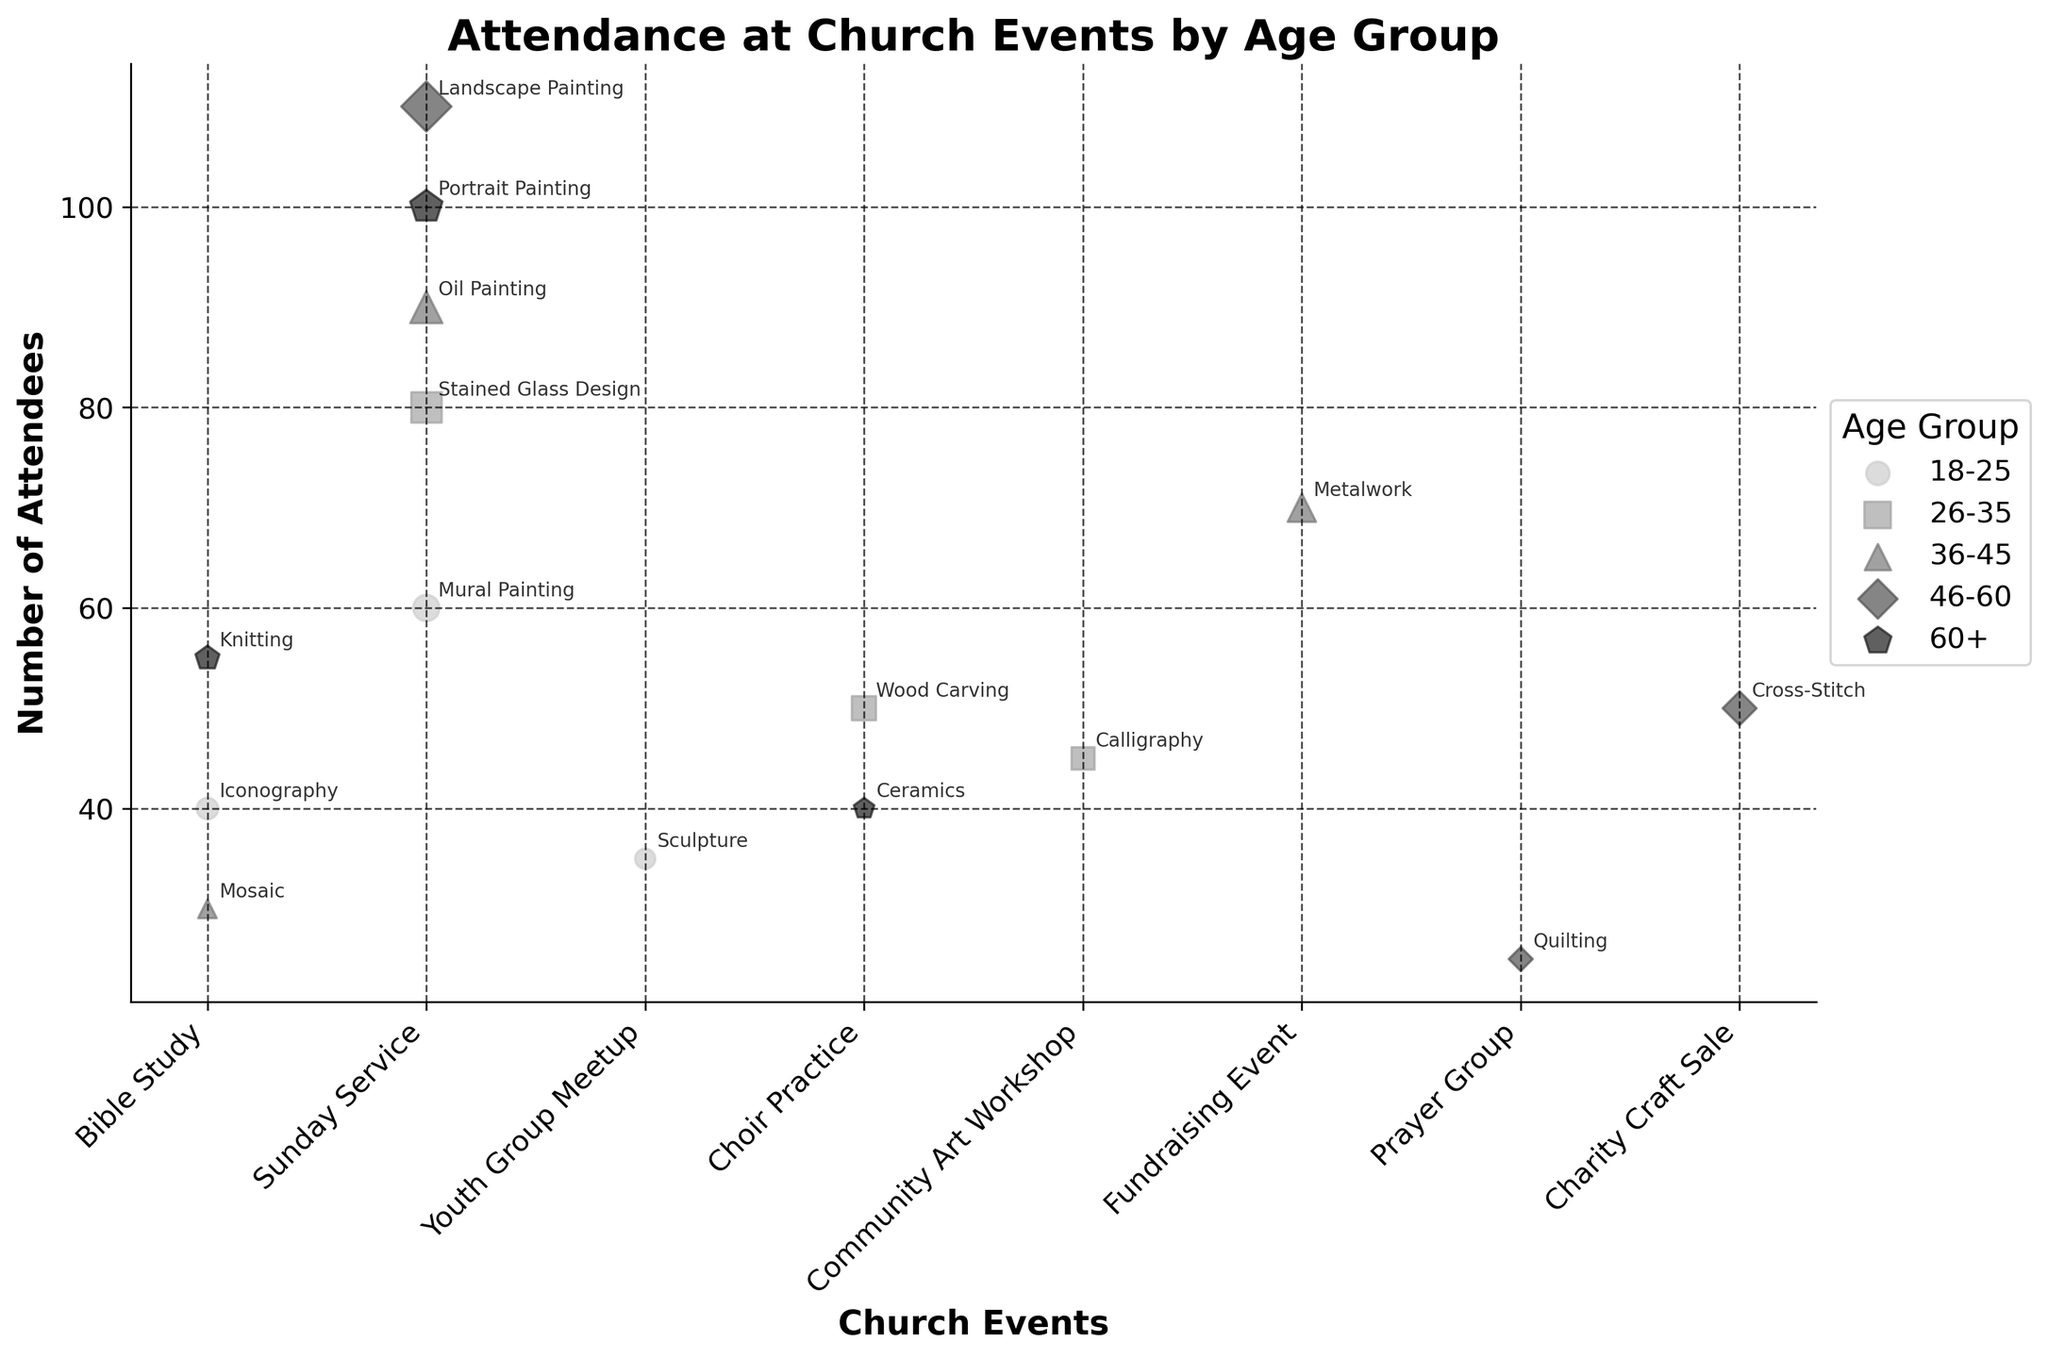what's the title of the plot? The title of the plot is displayed at the top in a larger, bold font. It provides a summary of what the plot represents. Look at the top of the chart to find the title.
Answer: Attendance at Church Events by Age Group how many attendees are there at the Community Art Workshop for age group 26-35? Identify the marker for the Community Art Workshop event and the age group 26-35, then look at the y-axis value where the marker is positioned.
Answer: 45 which age group has the highest attendance at Sunday Service? Compare the markers labeled 'Sunday Service' for all age groups and find which one is placed highest on the y-axis.
Answer: 46-60 what artistic interest is associated with the event that has 70 attendees for the age group 36-45? Locate the marker for the age group 36-45 with 70 attendees, find the corresponding event, and look at the annotation next to it that indicates the artistic interest.
Answer: Metalwork which event is most attended by the age group 18-25? Look for the markers associated with age group 18-25 and identify which one is positioned highest on the y-axis.
Answer: Sunday Service which age group participates in Choir Practice and what are their artistic interests? Find the markers labeled Choir Practice, then check the corresponding age groups and annotations for artistic interests.
Answer: 26-35 (Wood Carving), 60+ (Ceramics) what is the average number of attendees at Bible Study across all age groups? Identify all the markers labeled Bible Study, sum up the attendees, and divide by the number of such events. For 18-25 (40), 36-45 (30), 60+ (55), the sum is 40 + 30 + 55 = 125. The average is 125/3.
Answer: 41.67 which age group attends at most three different church events? Look at each age group and count the distinct events they attend. The age group with at most three events will be the answer.
Answer: 60+ compare the number of attendees at Bible Study for age groups 18-25 and 36-45. Which one is larger, and by how much? Find the attendee numbers for Bible Study in age groups 18-25 and 36-45, subtract the smaller from the larger to find the difference. For 18-25 (40) and 36-45 (30), the difference is 40 - 30.
Answer: 10 how do the artistic interests of the highest attended event differ by age group? Identify the highest attended events, check the related annotations for each age group, and compare the artistic interests noted.
Answer: Acrylic (46-60), Oil (60+) 